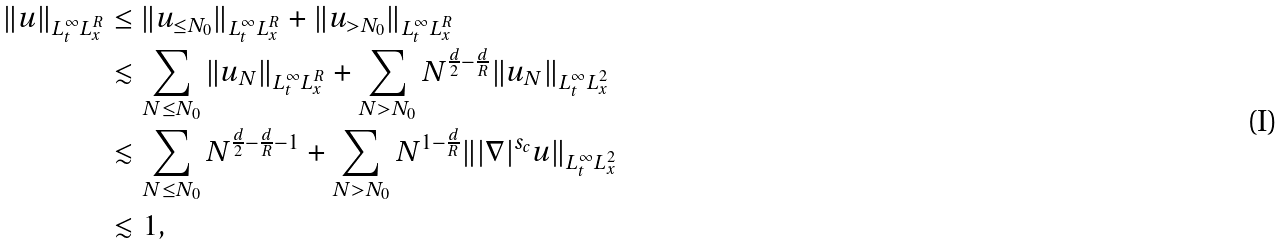Convert formula to latex. <formula><loc_0><loc_0><loc_500><loc_500>\| u \| _ { L _ { t } ^ { \infty } L _ { x } ^ { R } } & \leq \| u _ { \leq N _ { 0 } } \| _ { L _ { t } ^ { \infty } L _ { x } ^ { R } } + \| u _ { > N _ { 0 } } \| _ { L _ { t } ^ { \infty } L _ { x } ^ { R } } \\ & \lesssim \sum _ { N \leq N _ { 0 } } \| u _ { N } \| _ { L _ { t } ^ { \infty } L _ { x } ^ { R } } + \sum _ { N > N _ { 0 } } N ^ { \frac { d } { 2 } - \frac { d } { R } } \| u _ { N } \| _ { L _ { t } ^ { \infty } L _ { x } ^ { 2 } } \\ & \lesssim \sum _ { N \leq N _ { 0 } } N ^ { \frac { d } { 2 } - \frac { d } { R } - 1 } + \sum _ { N > N _ { 0 } } N ^ { 1 - \frac { d } { R } } \| | \nabla | ^ { s _ { c } } u \| _ { L _ { t } ^ { \infty } L _ { x } ^ { 2 } } \\ & \lesssim 1 ,</formula> 